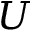<formula> <loc_0><loc_0><loc_500><loc_500>U</formula> 